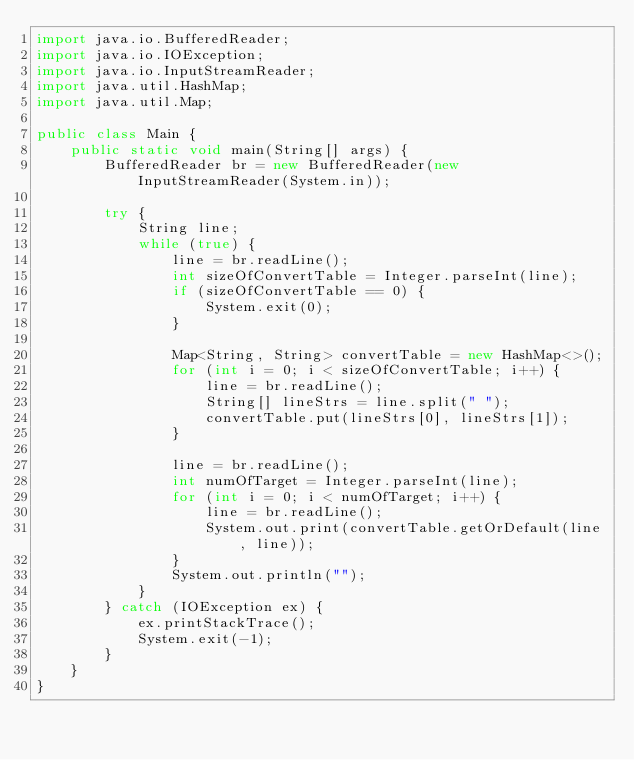<code> <loc_0><loc_0><loc_500><loc_500><_Java_>import java.io.BufferedReader;
import java.io.IOException;
import java.io.InputStreamReader;
import java.util.HashMap;
import java.util.Map;

public class Main {
    public static void main(String[] args) {
        BufferedReader br = new BufferedReader(new InputStreamReader(System.in));

        try {
            String line;
            while (true) {
                line = br.readLine();
                int sizeOfConvertTable = Integer.parseInt(line);
                if (sizeOfConvertTable == 0) {
                    System.exit(0);
                }

                Map<String, String> convertTable = new HashMap<>();
                for (int i = 0; i < sizeOfConvertTable; i++) {
                    line = br.readLine();
                    String[] lineStrs = line.split(" ");
                    convertTable.put(lineStrs[0], lineStrs[1]);
                }

                line = br.readLine();
                int numOfTarget = Integer.parseInt(line);
                for (int i = 0; i < numOfTarget; i++) {
                    line = br.readLine();
                    System.out.print(convertTable.getOrDefault(line, line));
                }
                System.out.println("");
            }
        } catch (IOException ex) {
            ex.printStackTrace();
            System.exit(-1);
        }
    }
}</code> 